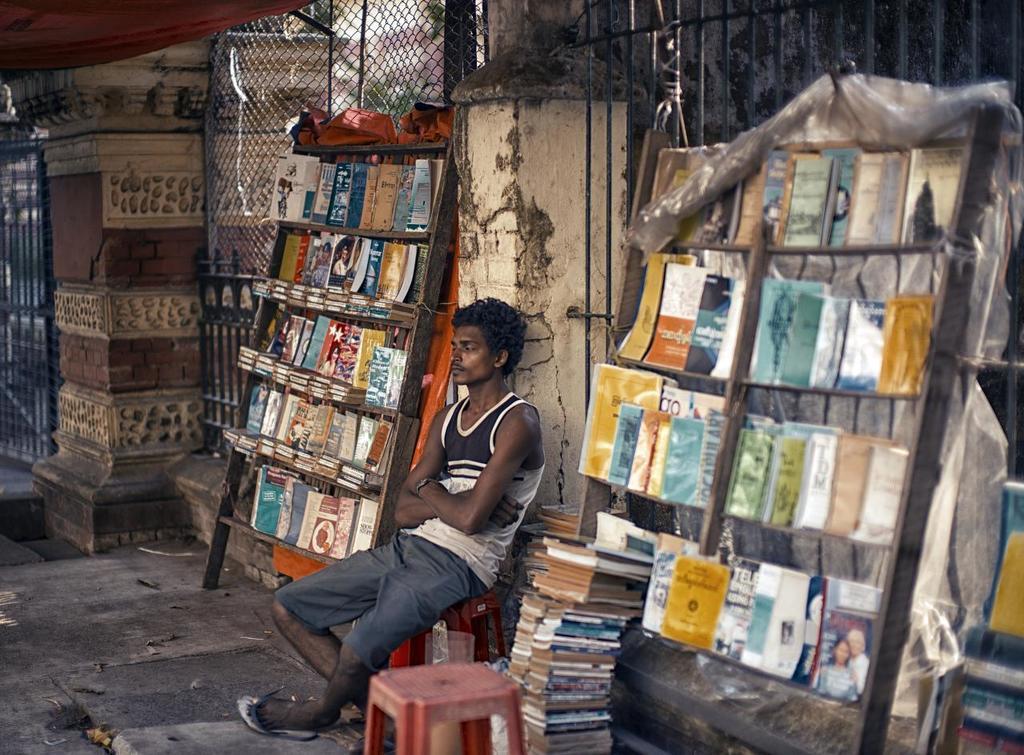Could you give a brief overview of what you see in this image? In this picture I can see few books on the wooden stands and I can see few books on the ground and a man seated on the stool and I can see another stool on the side and I can see a metal fence. 